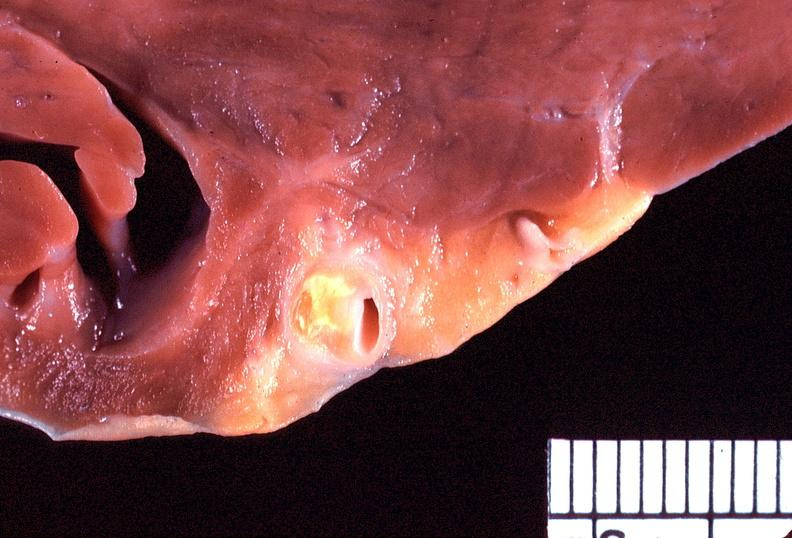s cardiovascular present?
Answer the question using a single word or phrase. Yes 